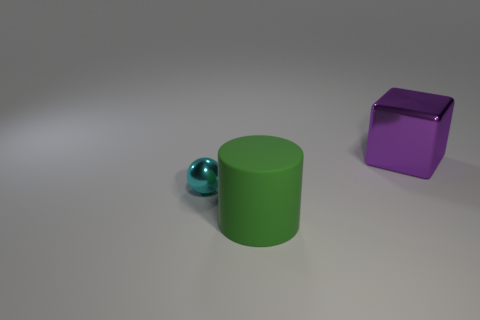What number of other green objects have the same material as the green thing? Based on the image, there are no other green objects with the same material as the green cylinder. The only other object in the image is a purple cube, which has a different color and, upon close inspection, a distinct material finish. 